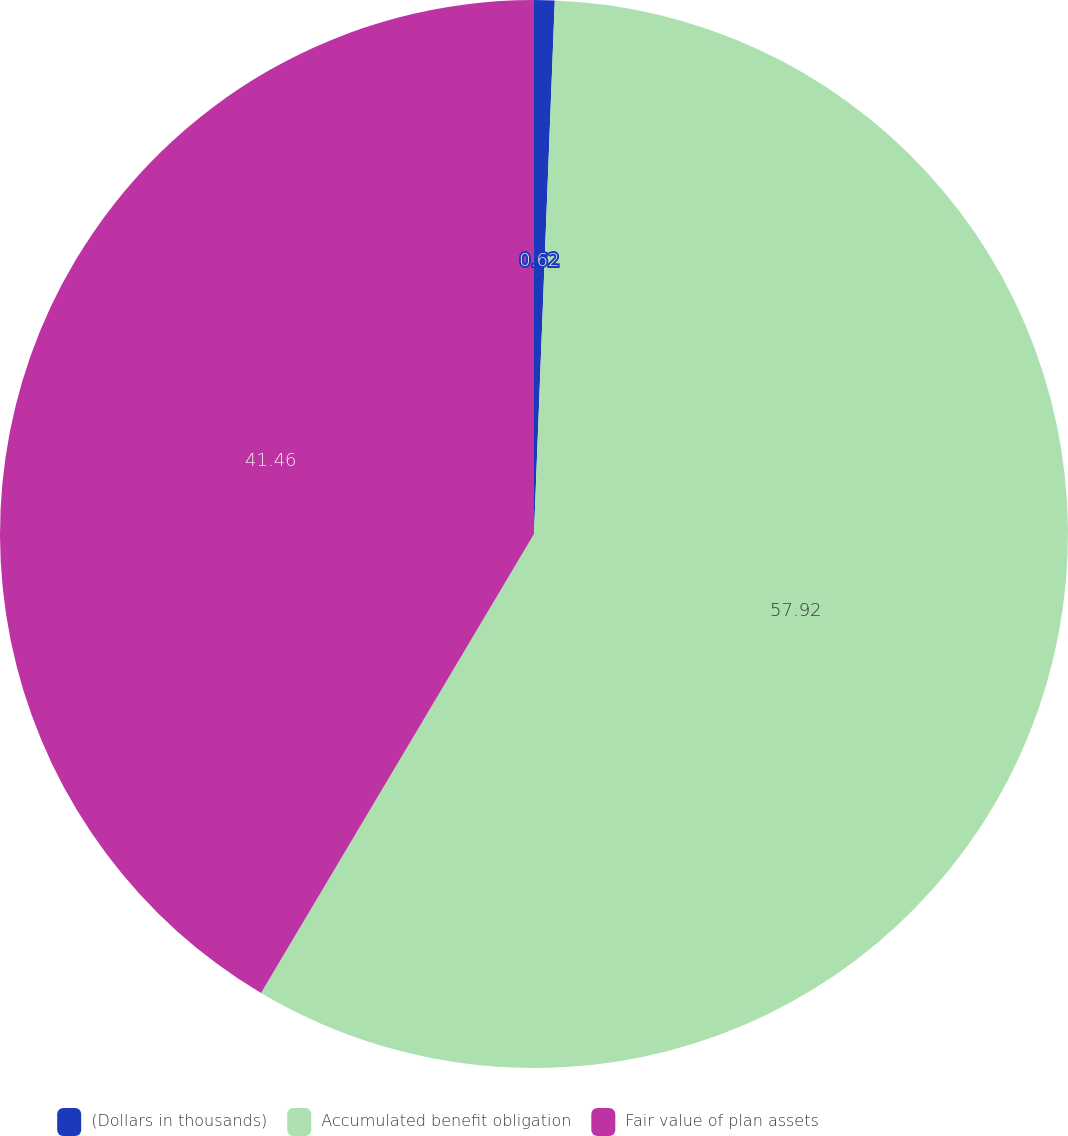<chart> <loc_0><loc_0><loc_500><loc_500><pie_chart><fcel>(Dollars in thousands)<fcel>Accumulated benefit obligation<fcel>Fair value of plan assets<nl><fcel>0.62%<fcel>57.92%<fcel>41.46%<nl></chart> 